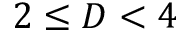<formula> <loc_0><loc_0><loc_500><loc_500>2 \leq D < 4</formula> 